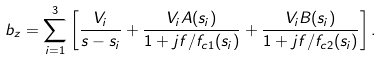<formula> <loc_0><loc_0><loc_500><loc_500>b _ { z } = \sum _ { i = 1 } ^ { 3 } \left [ \frac { V _ { i } } { s - s _ { i } } + \frac { V _ { i } A ( s _ { i } ) } { 1 + j f / f _ { c 1 } ( s _ { i } ) } + \frac { V _ { i } B ( s _ { i } ) } { 1 + j f / f _ { c 2 } ( s _ { i } ) } \right ] .</formula> 